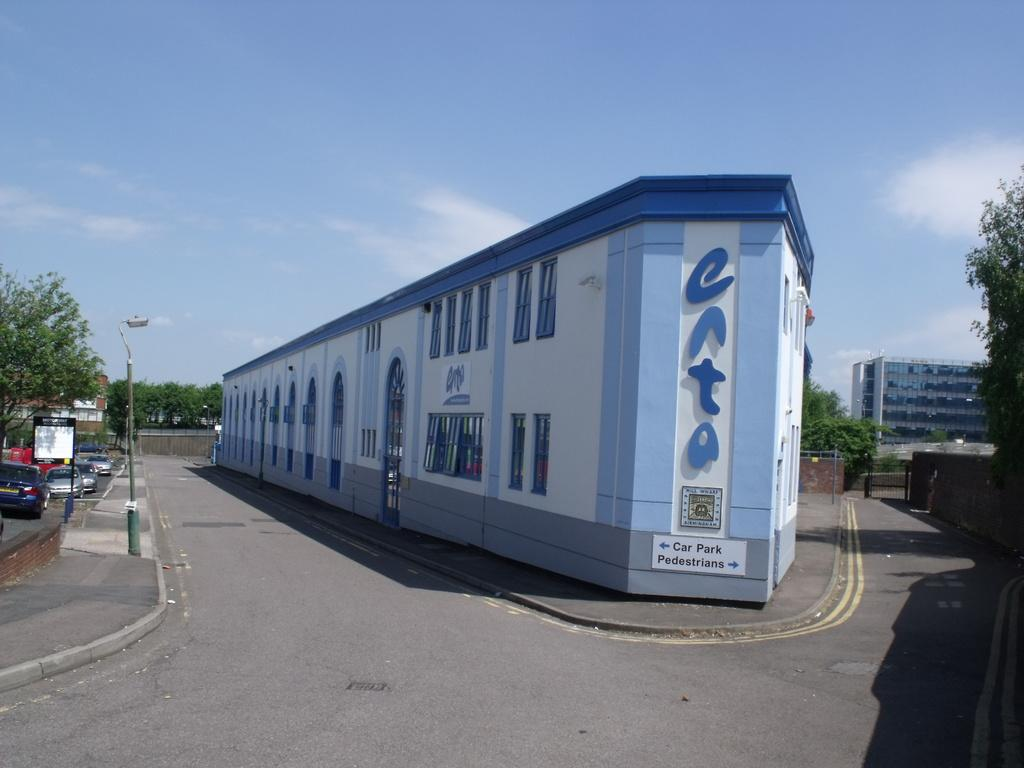Provide a one-sentence caption for the provided image. A building with car park and pedestrians on it. 